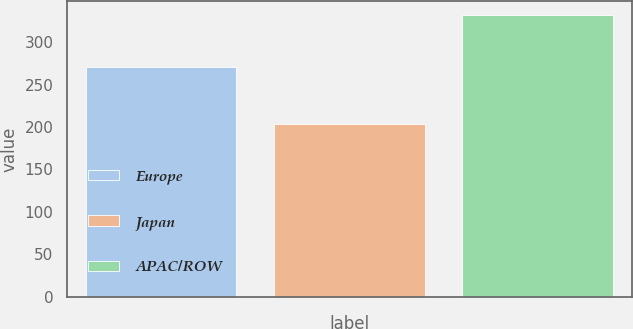Convert chart to OTSL. <chart><loc_0><loc_0><loc_500><loc_500><bar_chart><fcel>Europe<fcel>Japan<fcel>APAC/ROW<nl><fcel>270.3<fcel>203.6<fcel>331.4<nl></chart> 